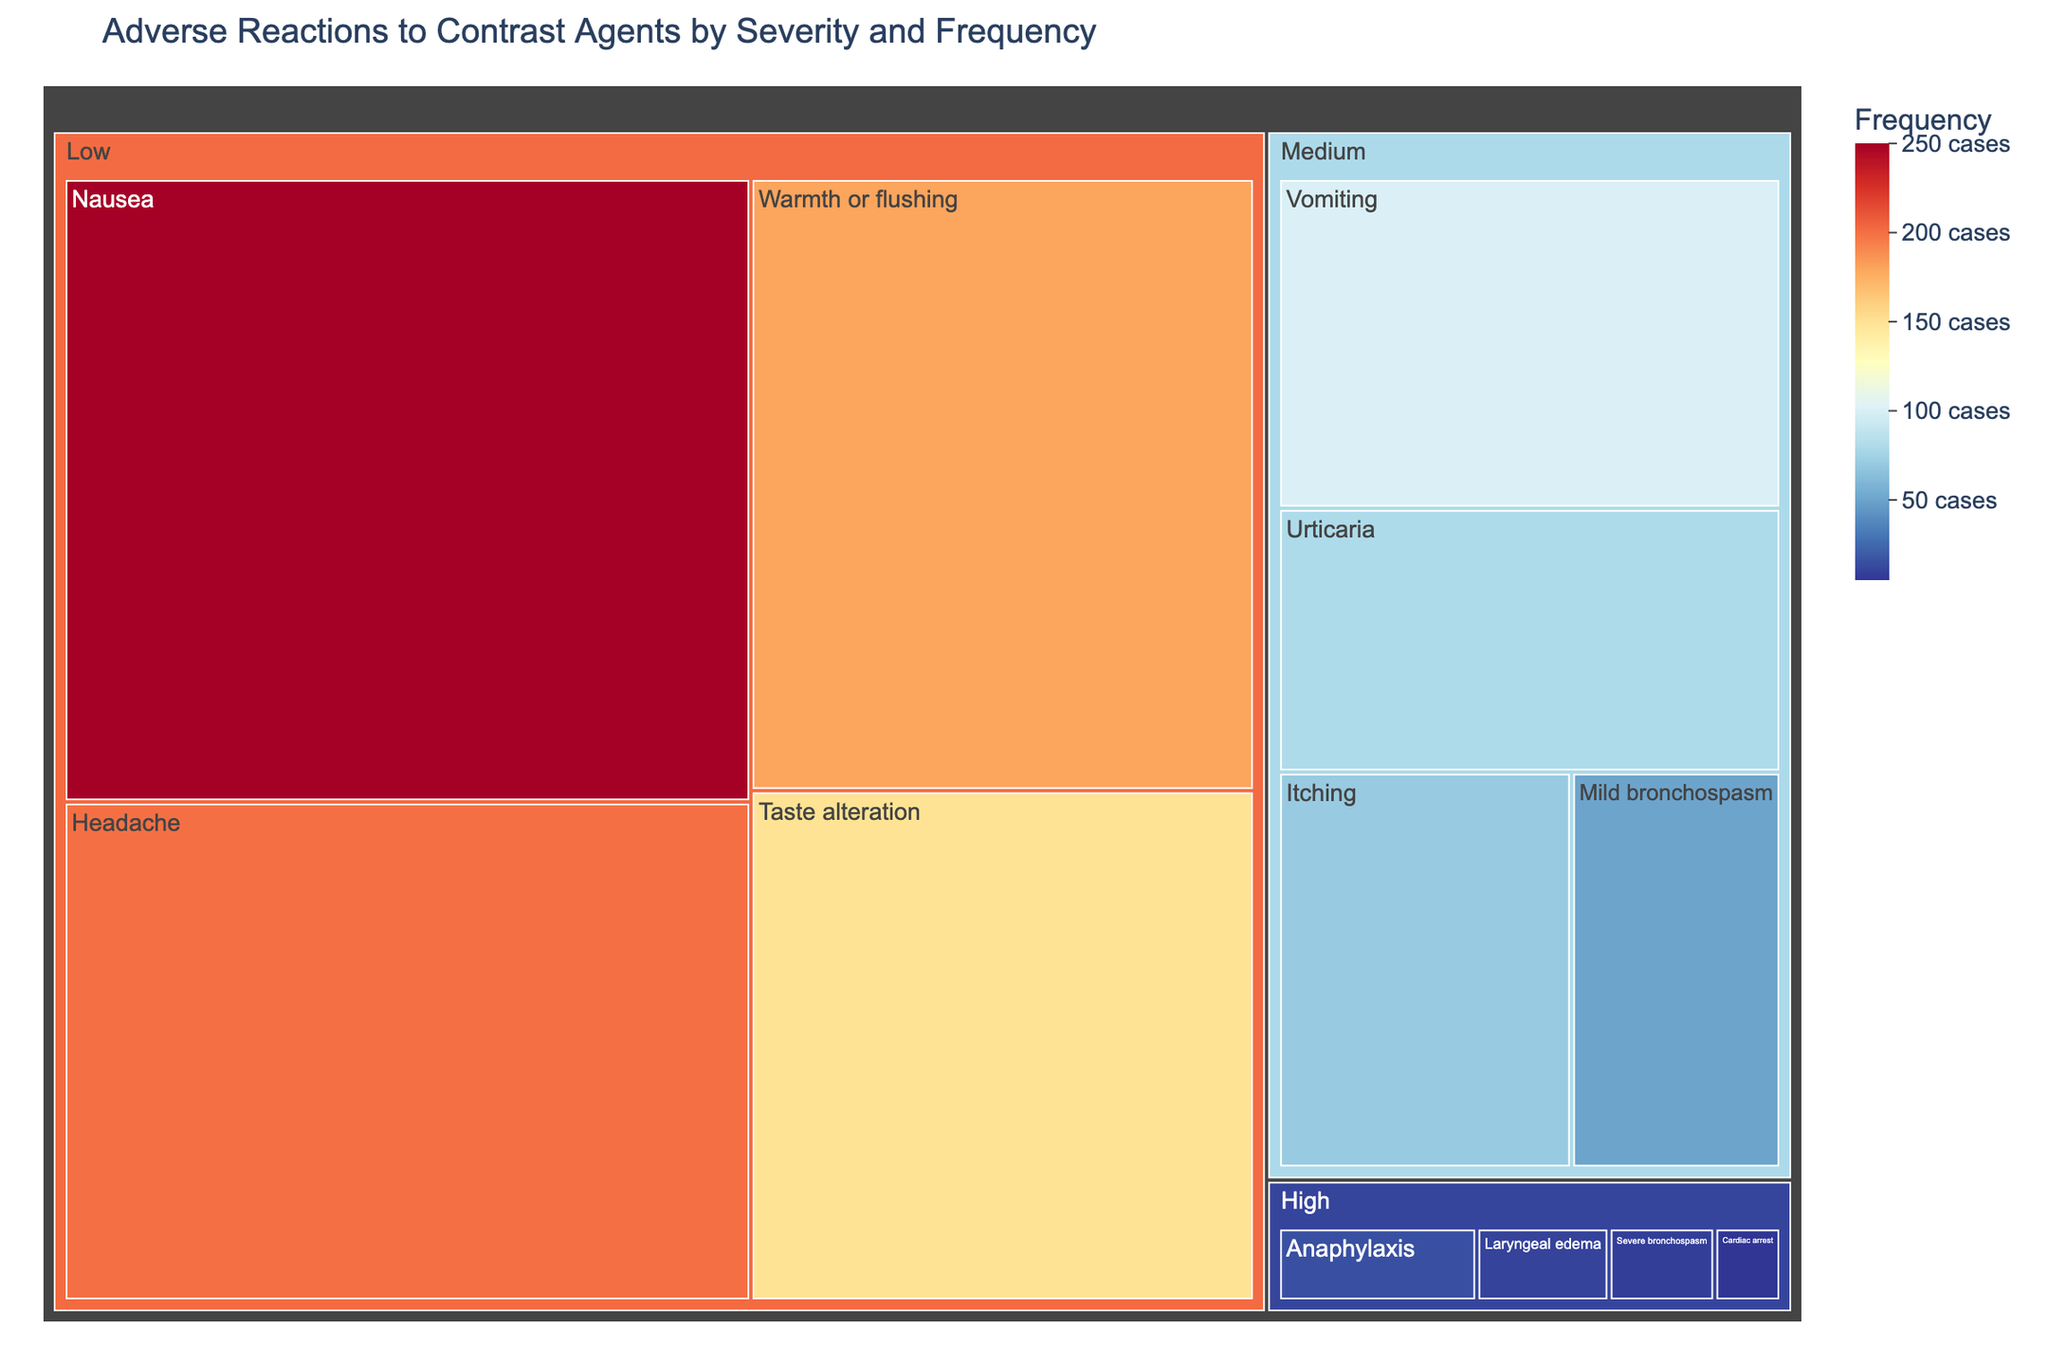What is the title of the treemap? The title of the treemap is located at the top of the figure. The title reads: "Adverse Reactions to Contrast Agents by Severity and Frequency."
Answer: Adverse Reactions to Contrast Agents by Severity and Frequency Which adverse reaction has the highest frequency in the 'Mild' category? Look at the 'Mild' category and identify the reaction with the largest area and highest frequency number. "Nausea" has the highest frequency in the 'Mild' category at 250 cases.
Answer: Nausea What is the combined frequency of all 'Severe' adverse reactions? Sum the frequencies of all reactions in the 'Severe' category: Anaphylaxis (15) + Laryngeal edema (10) + Severe bronchospasm (8) + Cardiac arrest (5) = 15 + 10 + 8 + 5 = 38.
Answer: 38 Which severity category contains the reaction with the lowest frequency? Identify the reaction with the smallest area and check its category. "Cardiac arrest" has the lowest frequency at 5 cases, and it falls under the 'Severe' category.
Answer: Severe How many different reactions are in the 'Moderate' category? Count the number of unique reactions in the 'Moderate' category. The reactions are Vomiting, Urticaria, Itching, and Mild bronchospasm, which makes a total of 4.
Answer: 4 Which reaction in the 'Moderate' category has the second-highest frequency? Within the 'Moderate' category, rank the reactions by frequency. Vomiting has 100 cases, Urticaria has 80 cases. Therefore, Urticaria has the second-highest frequency.
Answer: Urticaria Compare the frequency of 'Anaphylaxis' and 'Laryngeal edema'. Which one is higher and by how much? 'Anaphylaxis' has a frequency of 15 and 'Laryngeal edema' has a frequency of 10. The difference in frequency is 15 - 10 = 5, and 'Anaphylaxis' is higher.
Answer: Anaphylaxis by 5 What is the average frequency of reactions in the 'Mild' category? First, sum the frequencies: Nausea (250) + Headache (200) + Warmth or flushing (180) + Taste alteration (150) = 780 cases. Then, divide by the number of reactions (4): 780 / 4 = 195.
Answer: 195 What color scale is used to represent the frequency in the treemap? The color scale in the treemap is a reverse of the 'RdYlBu' color scale from plotly, which ranges from blue to red.
Answer: RdYlBu reversed 